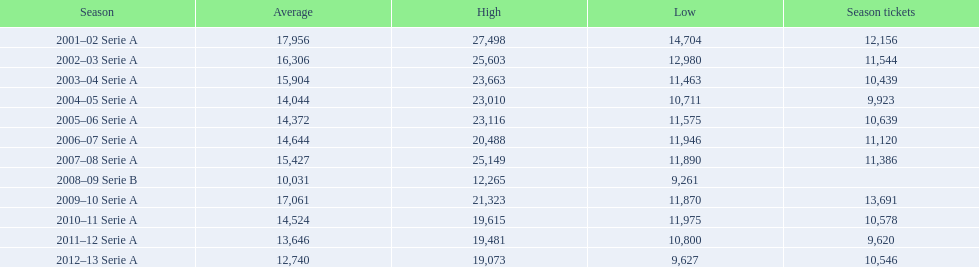In how many seasons was the average attendance at stadio ennio tardini no less than 15,000? 5. 